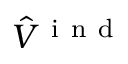<formula> <loc_0><loc_0><loc_500><loc_500>\hat { V } ^ { i n d }</formula> 